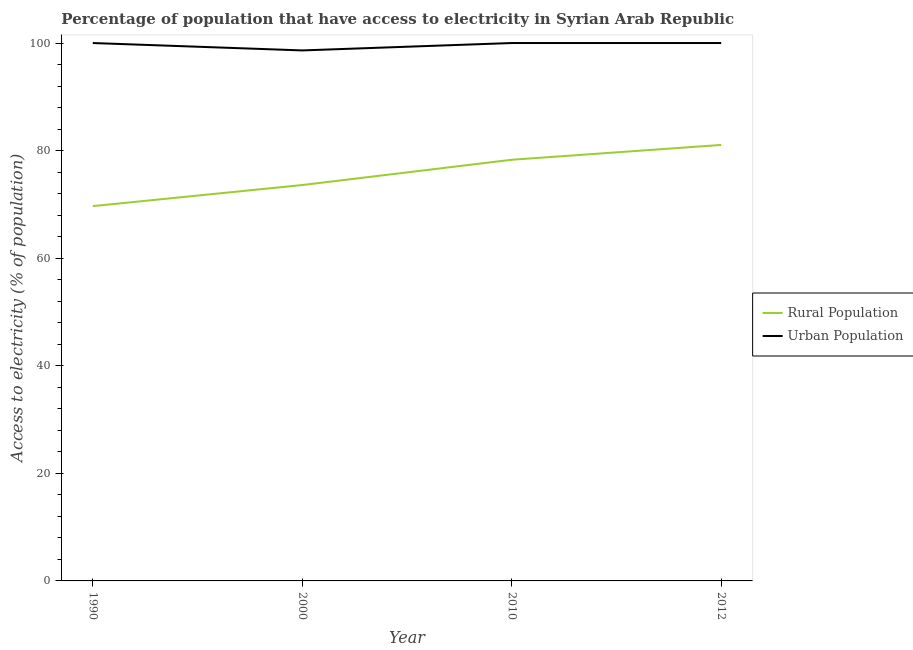What is the percentage of rural population having access to electricity in 2000?
Ensure brevity in your answer.  73.6. Across all years, what is the maximum percentage of rural population having access to electricity?
Your response must be concise. 81.05. Across all years, what is the minimum percentage of rural population having access to electricity?
Offer a very short reply. 69.68. In which year was the percentage of rural population having access to electricity minimum?
Your answer should be compact. 1990. What is the total percentage of rural population having access to electricity in the graph?
Offer a very short reply. 302.63. What is the difference between the percentage of rural population having access to electricity in 2010 and that in 2012?
Provide a succinct answer. -2.75. What is the difference between the percentage of rural population having access to electricity in 1990 and the percentage of urban population having access to electricity in 2000?
Offer a very short reply. -28.95. What is the average percentage of rural population having access to electricity per year?
Your response must be concise. 75.66. In the year 2012, what is the difference between the percentage of urban population having access to electricity and percentage of rural population having access to electricity?
Offer a terse response. 18.95. What is the ratio of the percentage of urban population having access to electricity in 2000 to that in 2012?
Offer a very short reply. 0.99. Is the percentage of rural population having access to electricity in 2000 less than that in 2012?
Offer a terse response. Yes. What is the difference between the highest and the second highest percentage of rural population having access to electricity?
Offer a terse response. 2.75. What is the difference between the highest and the lowest percentage of urban population having access to electricity?
Make the answer very short. 1.37. In how many years, is the percentage of rural population having access to electricity greater than the average percentage of rural population having access to electricity taken over all years?
Provide a succinct answer. 2. Is the sum of the percentage of urban population having access to electricity in 2000 and 2010 greater than the maximum percentage of rural population having access to electricity across all years?
Your response must be concise. Yes. How many years are there in the graph?
Your answer should be compact. 4. What is the difference between two consecutive major ticks on the Y-axis?
Your answer should be compact. 20. Are the values on the major ticks of Y-axis written in scientific E-notation?
Give a very brief answer. No. Does the graph contain grids?
Provide a succinct answer. No. Where does the legend appear in the graph?
Give a very brief answer. Center right. What is the title of the graph?
Your answer should be very brief. Percentage of population that have access to electricity in Syrian Arab Republic. Does "Underweight" appear as one of the legend labels in the graph?
Offer a terse response. No. What is the label or title of the Y-axis?
Make the answer very short. Access to electricity (% of population). What is the Access to electricity (% of population) in Rural Population in 1990?
Offer a very short reply. 69.68. What is the Access to electricity (% of population) in Rural Population in 2000?
Offer a very short reply. 73.6. What is the Access to electricity (% of population) in Urban Population in 2000?
Your response must be concise. 98.63. What is the Access to electricity (% of population) of Rural Population in 2010?
Provide a succinct answer. 78.3. What is the Access to electricity (% of population) in Rural Population in 2012?
Offer a terse response. 81.05. Across all years, what is the maximum Access to electricity (% of population) of Rural Population?
Your answer should be very brief. 81.05. Across all years, what is the minimum Access to electricity (% of population) of Rural Population?
Ensure brevity in your answer.  69.68. Across all years, what is the minimum Access to electricity (% of population) of Urban Population?
Ensure brevity in your answer.  98.63. What is the total Access to electricity (% of population) of Rural Population in the graph?
Give a very brief answer. 302.63. What is the total Access to electricity (% of population) of Urban Population in the graph?
Your response must be concise. 398.63. What is the difference between the Access to electricity (% of population) of Rural Population in 1990 and that in 2000?
Your response must be concise. -3.92. What is the difference between the Access to electricity (% of population) of Urban Population in 1990 and that in 2000?
Make the answer very short. 1.37. What is the difference between the Access to electricity (% of population) in Rural Population in 1990 and that in 2010?
Provide a succinct answer. -8.62. What is the difference between the Access to electricity (% of population) in Rural Population in 1990 and that in 2012?
Give a very brief answer. -11.38. What is the difference between the Access to electricity (% of population) of Urban Population in 1990 and that in 2012?
Your answer should be compact. 0. What is the difference between the Access to electricity (% of population) of Rural Population in 2000 and that in 2010?
Make the answer very short. -4.7. What is the difference between the Access to electricity (% of population) in Urban Population in 2000 and that in 2010?
Offer a terse response. -1.37. What is the difference between the Access to electricity (% of population) of Rural Population in 2000 and that in 2012?
Your answer should be compact. -7.45. What is the difference between the Access to electricity (% of population) in Urban Population in 2000 and that in 2012?
Make the answer very short. -1.37. What is the difference between the Access to electricity (% of population) in Rural Population in 2010 and that in 2012?
Your answer should be very brief. -2.75. What is the difference between the Access to electricity (% of population) of Urban Population in 2010 and that in 2012?
Make the answer very short. 0. What is the difference between the Access to electricity (% of population) of Rural Population in 1990 and the Access to electricity (% of population) of Urban Population in 2000?
Provide a short and direct response. -28.95. What is the difference between the Access to electricity (% of population) in Rural Population in 1990 and the Access to electricity (% of population) in Urban Population in 2010?
Offer a terse response. -30.32. What is the difference between the Access to electricity (% of population) in Rural Population in 1990 and the Access to electricity (% of population) in Urban Population in 2012?
Your answer should be compact. -30.32. What is the difference between the Access to electricity (% of population) in Rural Population in 2000 and the Access to electricity (% of population) in Urban Population in 2010?
Make the answer very short. -26.4. What is the difference between the Access to electricity (% of population) of Rural Population in 2000 and the Access to electricity (% of population) of Urban Population in 2012?
Your answer should be compact. -26.4. What is the difference between the Access to electricity (% of population) in Rural Population in 2010 and the Access to electricity (% of population) in Urban Population in 2012?
Your answer should be very brief. -21.7. What is the average Access to electricity (% of population) in Rural Population per year?
Provide a short and direct response. 75.66. What is the average Access to electricity (% of population) of Urban Population per year?
Ensure brevity in your answer.  99.66. In the year 1990, what is the difference between the Access to electricity (% of population) of Rural Population and Access to electricity (% of population) of Urban Population?
Your answer should be compact. -30.32. In the year 2000, what is the difference between the Access to electricity (% of population) of Rural Population and Access to electricity (% of population) of Urban Population?
Your response must be concise. -25.03. In the year 2010, what is the difference between the Access to electricity (% of population) of Rural Population and Access to electricity (% of population) of Urban Population?
Your response must be concise. -21.7. In the year 2012, what is the difference between the Access to electricity (% of population) of Rural Population and Access to electricity (% of population) of Urban Population?
Your answer should be compact. -18.95. What is the ratio of the Access to electricity (% of population) of Rural Population in 1990 to that in 2000?
Provide a succinct answer. 0.95. What is the ratio of the Access to electricity (% of population) of Urban Population in 1990 to that in 2000?
Keep it short and to the point. 1.01. What is the ratio of the Access to electricity (% of population) in Rural Population in 1990 to that in 2010?
Provide a succinct answer. 0.89. What is the ratio of the Access to electricity (% of population) of Rural Population in 1990 to that in 2012?
Your answer should be very brief. 0.86. What is the ratio of the Access to electricity (% of population) of Rural Population in 2000 to that in 2010?
Your answer should be very brief. 0.94. What is the ratio of the Access to electricity (% of population) of Urban Population in 2000 to that in 2010?
Your answer should be very brief. 0.99. What is the ratio of the Access to electricity (% of population) in Rural Population in 2000 to that in 2012?
Give a very brief answer. 0.91. What is the ratio of the Access to electricity (% of population) of Urban Population in 2000 to that in 2012?
Keep it short and to the point. 0.99. What is the ratio of the Access to electricity (% of population) in Rural Population in 2010 to that in 2012?
Keep it short and to the point. 0.97. What is the ratio of the Access to electricity (% of population) of Urban Population in 2010 to that in 2012?
Your response must be concise. 1. What is the difference between the highest and the second highest Access to electricity (% of population) of Rural Population?
Keep it short and to the point. 2.75. What is the difference between the highest and the lowest Access to electricity (% of population) of Rural Population?
Your response must be concise. 11.38. What is the difference between the highest and the lowest Access to electricity (% of population) in Urban Population?
Offer a terse response. 1.37. 